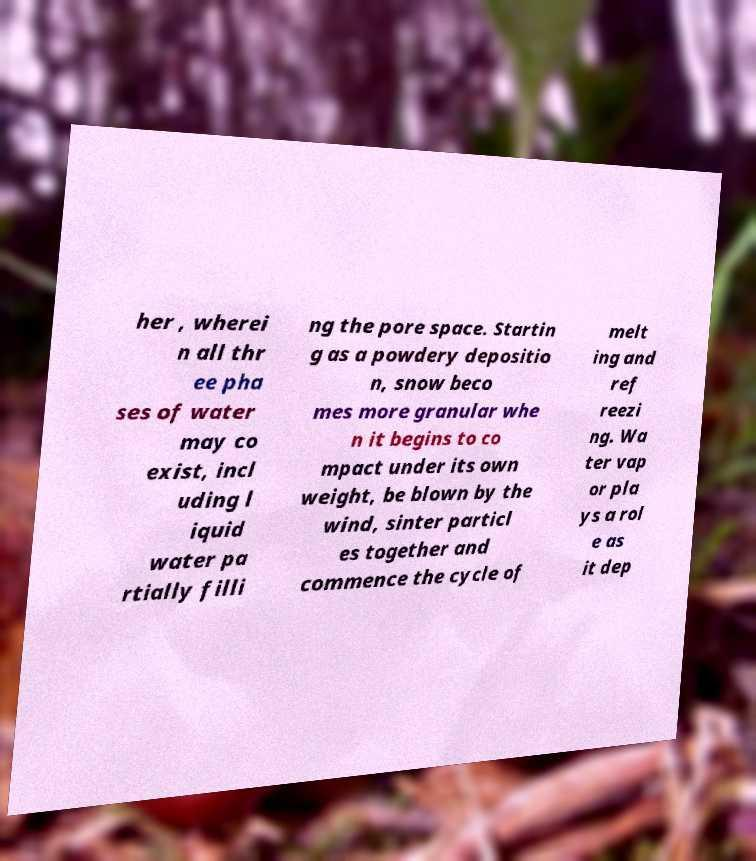Could you assist in decoding the text presented in this image and type it out clearly? her , wherei n all thr ee pha ses of water may co exist, incl uding l iquid water pa rtially filli ng the pore space. Startin g as a powdery depositio n, snow beco mes more granular whe n it begins to co mpact under its own weight, be blown by the wind, sinter particl es together and commence the cycle of melt ing and ref reezi ng. Wa ter vap or pla ys a rol e as it dep 